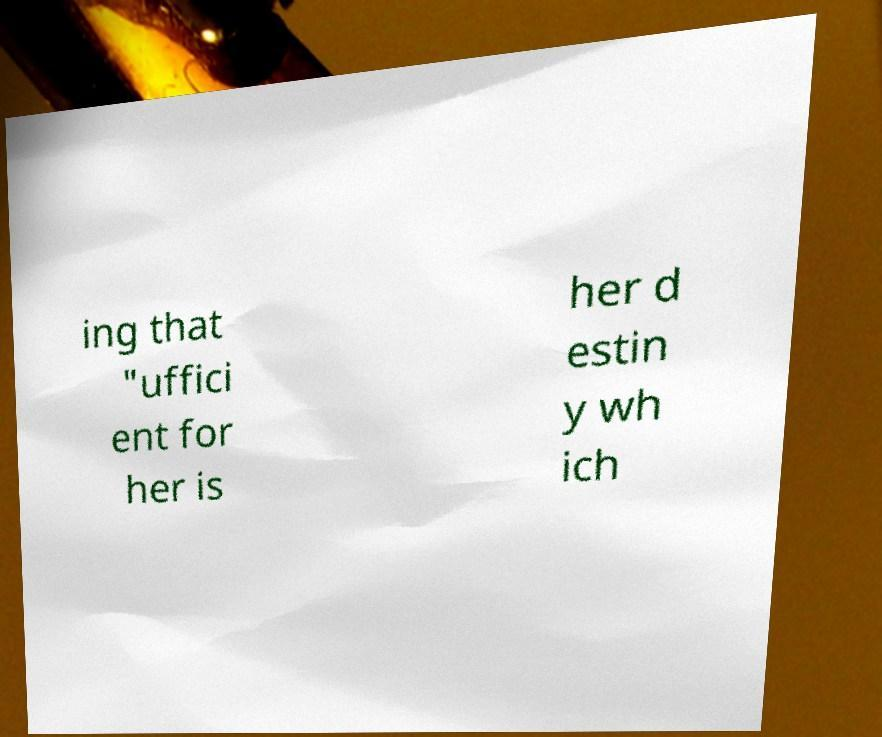I need the written content from this picture converted into text. Can you do that? ing that "uffici ent for her is her d estin y wh ich 